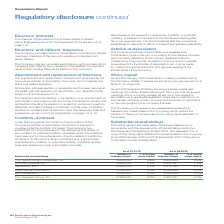According to Spirax Sarco Engineering Plc's financial document, How were the voting rights in the table determined? in accordance with the requirements of the UK Listing Authority’s Disclosure and Transparency Rules DTR 5. The document states: "ng rights in the table below have been determined in accordance with the requirements of the UK Listing Authority’s Disclosure and Transparency Rules ..." Also, What do the voting rights in the table represent? 3% or more of the voting rights attached to issued shares in the Company as at 28th February 2020 and 31st December 2019. The document states: "osure and Transparency Rules DTR 5, and represent 3% or more of the voting rights attached to issued shares in the Company as at 28th February 2020 an..." Also, What are the companies under substantial shareholdings in the table? The document contains multiple relevant values: The Capital Group Companies, Inc., Sun Life Financial, Inc., BlackRock, Inc., Fiera Capital Corporation, APG Groep N.V., The Vanguard Group, Inc.. From the document: "6.5% APG Groep N.V. 4,068,000 5.5% 4,068,000 5.5% The Vanguard Group, Inc. 2,569,081 3.5% 2,637,287 3.6% umber of Ordinary shares % of issued share ca..." Additionally, Which company has the largest % of issued share capital as at 28.02.20? The Capital Group Companies, Inc.. The document states: "umber of Ordinary shares % of issued share capital The Capital Group Companies, Inc. 6,584,006 8.9% 6,598,428 8.9% Sun Life Financial, Inc. 5,566,823 ..." Also, can you calculate: What was the change in the number of ordinary shares for BlackRock, Inc. in 2020 from 2019? Based on the calculation: 4,913,790-4,624,204, the result is 289586. This is based on the information: ".5% 5,481,561 7.4% BlackRock, Inc. 4,624,204 6.3% 4,913,790 6.7% Fiera Capital Corporation 4,764,251 6.5% 4,768,688 6.5% APG Groep N.V. 4,068,000 5.5% 4,068,00 nc. 5,566,823 7.5% 5,481,561 7.4% BlackR..." The key data points involved are: 4,624,204, 4,913,790. Also, can you calculate: What was the percentage change in the number of ordinary shares for BlackRock, Inc. in 2020 from 2019? To answer this question, I need to perform calculations using the financial data. The calculation is: (4,913,790-4,624,204)/4,624,204, which equals 6.26 (percentage). This is based on the information: ".5% 5,481,561 7.4% BlackRock, Inc. 4,624,204 6.3% 4,913,790 6.7% Fiera Capital Corporation 4,764,251 6.5% 4,768,688 6.5% APG Groep N.V. 4,068,000 5.5% 4,068,00 nc. 5,566,823 7.5% 5,481,561 7.4% BlackR..." The key data points involved are: 4,624,204, 4,913,790. 